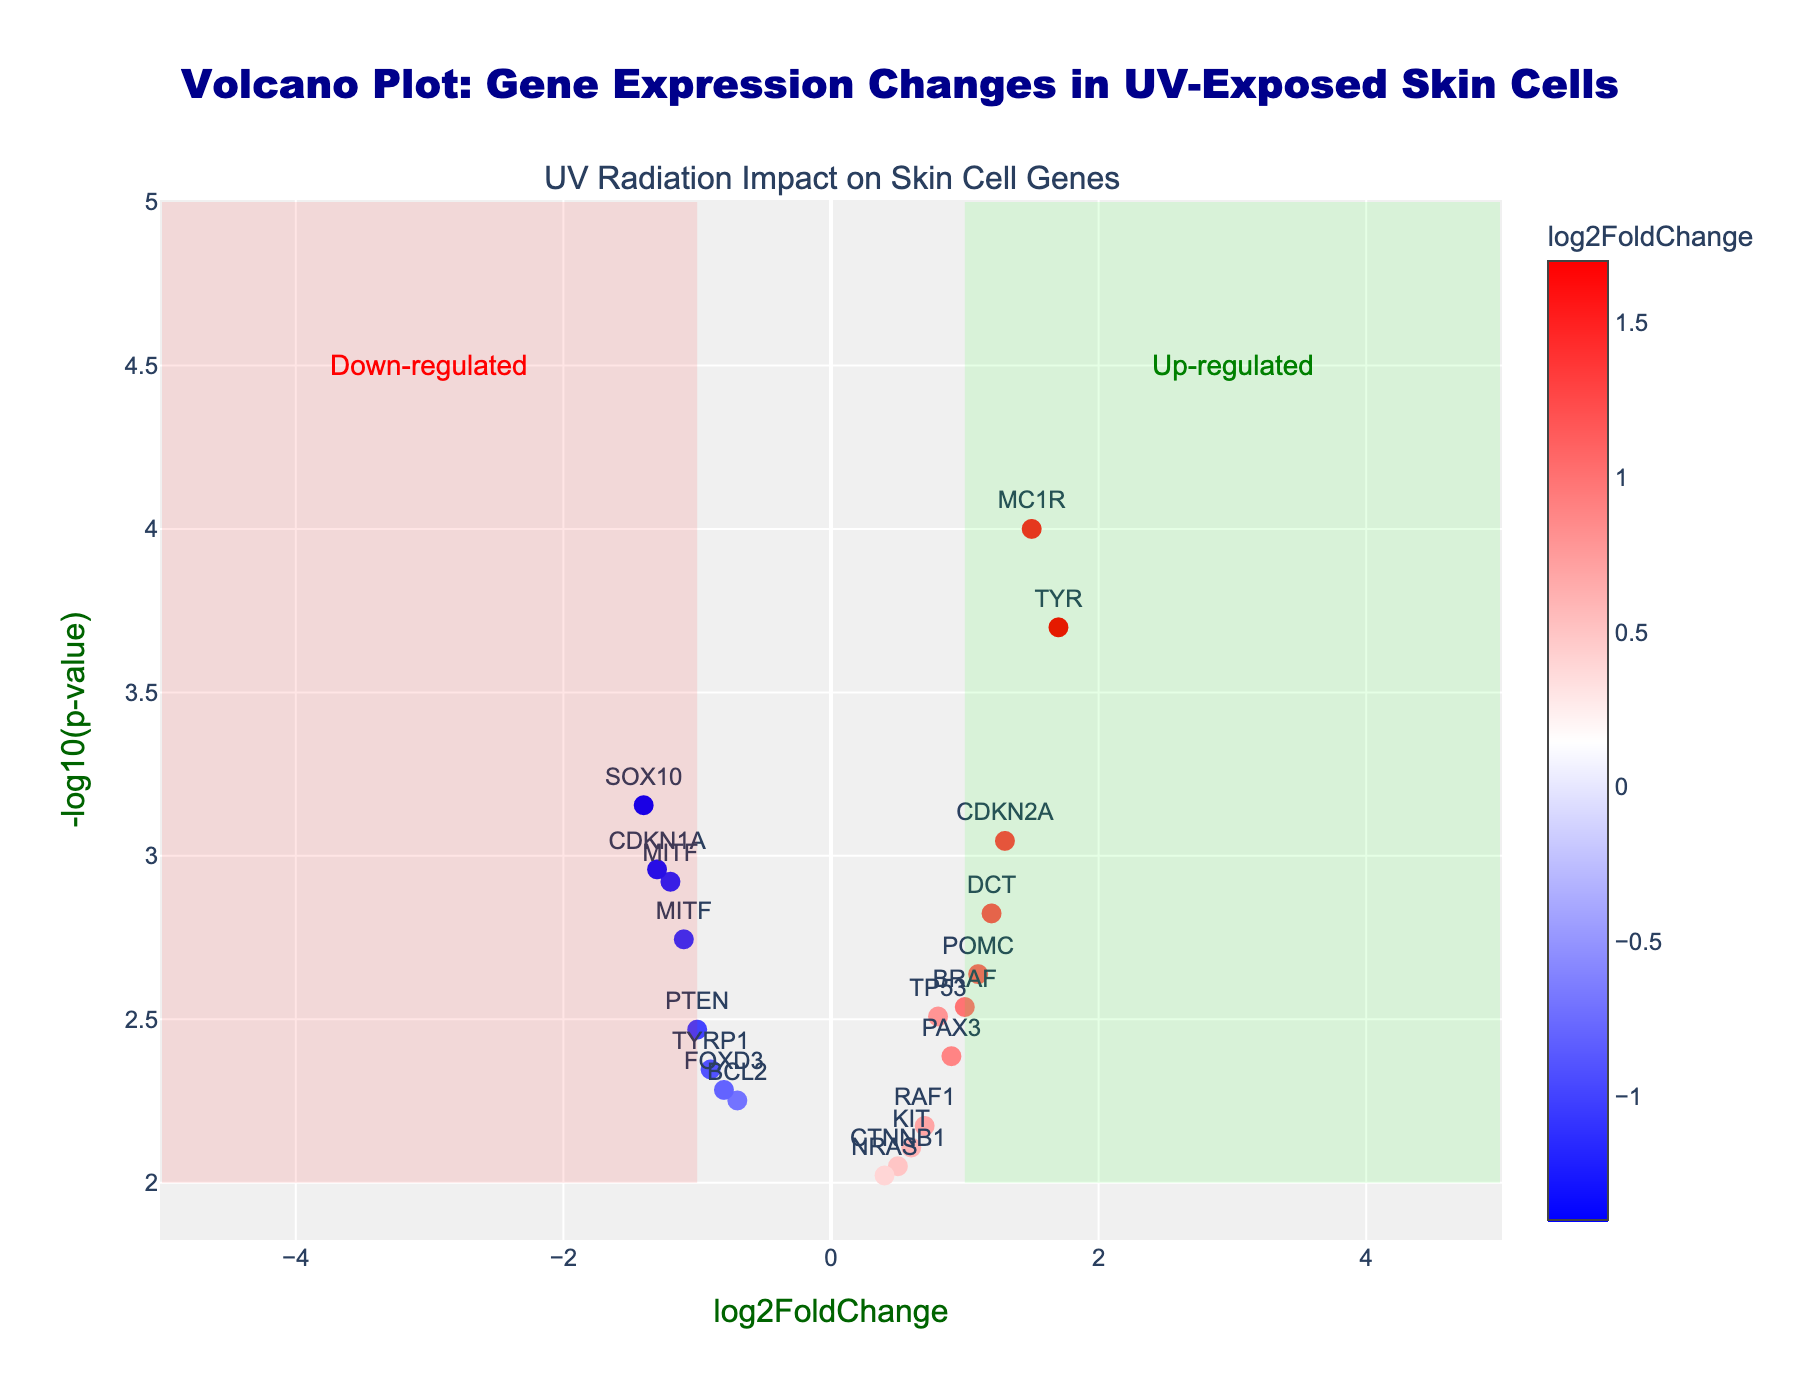Which gene has the smallest p-value? The gene with the smallest p-value will be at the highest point on the y-axis since the y-axis represents -log10(p-value). By examining the plot, we see that the gene TYR is at the highest point.
Answer: TYR How many genes are significantly up-regulated? Significantly up-regulated genes will have log2FoldChange > 1 and -log10(p-value) > 2. By counting the points in this region, we find 4 genes: MC1R, POMC, CDKN2A, and TYR.
Answer: 4 What is the log2FoldChange value for the gene BCL2? To find the log2FoldChange for BCL2, locate the point labeled BCL2 on the x-axis and read its value. BCL2 has a log2FoldChange of -0.7.
Answer: -0.7 Which gene is most down-regulated according to the plot? The most down-regulated gene will have the most negative log2FoldChange. By examining the points on the left side of the plot, we see that SOX10 has the lowest log2FoldChange value of -1.4.
Answer: SOX10 What is the range of -log10(p-value) values in the plot? To find the range, look for the smallest and largest -log10(p-value) on the y-axis. The smallest appears to be just above 2, while the largest is around 4.7. The range is from 2 to 4.7.
Answer: 2 to 4.7 Are there any genes with a log2FoldChange of exactly 0? A log2FoldChange of 0 would place the gene on the y-axis itself. Examining the plot, there are no points on the y-axis, indicating no genes have a log2FoldChange of 0.
Answer: No Which gene has the highest log2FoldChange and what is its value? The gene with the highest log2FoldChange will be the point farthest to the right. The gene TYR is the farthest to the right with a log2FoldChange of 1.7.
Answer: TYR, 1.7 Compare the p-values of genes MITF and KIT. Which one is smaller and by how much? To compare the p-values, find each gene's position on the y-axis and convert -log10(p-value) back to p-value. MITF has a -log10(p-value) of around 3.12 (p = 0.0012) and KIT has a -log10(p-value) of around 2.11 (p = 0.0078). Therefore, MITF's p-value is smaller by 0.0078 - 0.0012 = 0.0066.
Answer: MITF, 0.0066 How many genes are both significantly up-regulated and have p-values less than 0.002? To count these genes, look for points with log2FoldChange > 1 and -log10(p-value) > 2.7 (since -log10(0.002) ≈ 2.7). Only two points fit this criterion: MC1R and TYR.
Answer: 2 